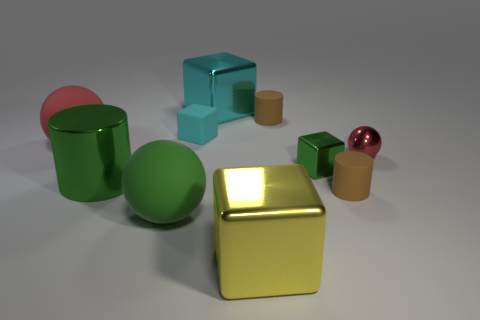How many objects are in the image, and can you describe their shapes and colors? There are nine objects present. These include three cubes, one in gold, one in teal, and a smaller one in red; two cylinders, one large green one and a smaller beige one; two spheres, one small red and the other large pink, and two toruses, one large red and one smaller in beige. 